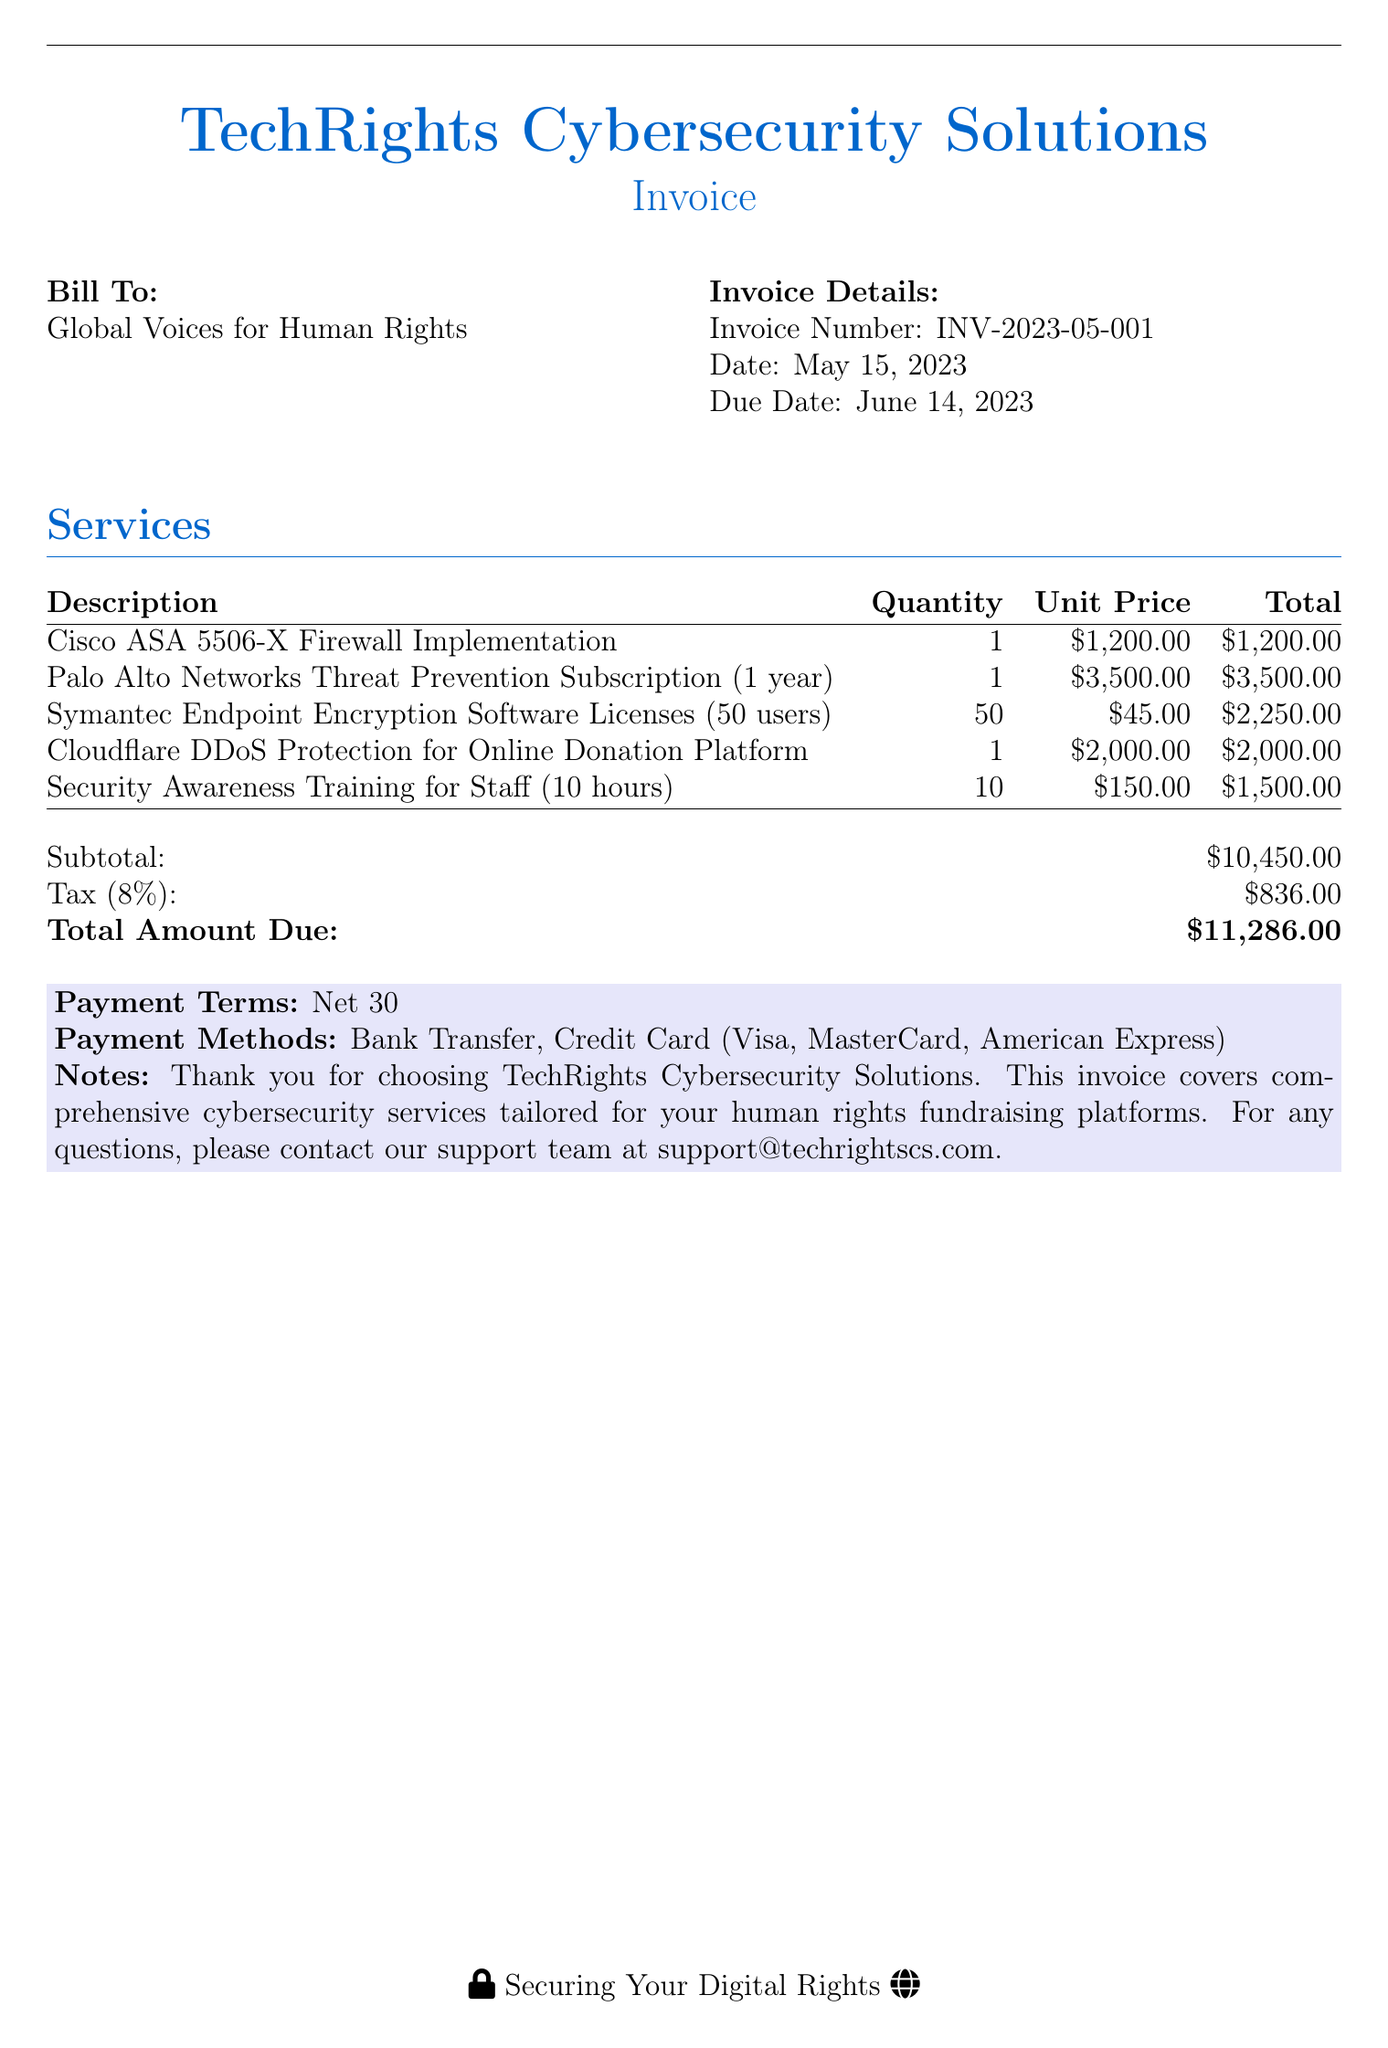What is the invoice number? The invoice number is stated clearly under the Invoice Details section.
Answer: INV-2023-05-001 What is the due date? The due date is provided in the Invoice Details section, indicating when the payment is expected.
Answer: June 14, 2023 What is the total amount due? The total amount due is listed at the end of the invoice, summarizing the subtotal and tax.
Answer: $11,286.00 What is the quantity for the firewall implementation? The quantity for the Cisco ASA 5506-X Firewall Implementation service is mentioned in the Services table.
Answer: 1 What service has the highest unit price? The unit prices for the services are compared to find the one with the highest cost.
Answer: Palo Alto Networks Threat Prevention Subscription (1 year) What are the payment methods? The payment methods are outlined at the bottom of the invoice under Payment Methods.
Answer: Bank Transfer, Credit Card (Visa, MasterCard, American Express) What is the tax rate applied? The tax rate is explicitly stated next to the tax amount in the Invoicing section.
Answer: 8% How many users are covered by the Symantec software licenses? The number of users for the Symantec Endpoint Encryption Software Licenses is specified in the Services table.
Answer: 50 users What is the total for Security Awareness Training? The total amount for Security Awareness Training is calculated based on the unit price and quantity listed.
Answer: $1,500.00 